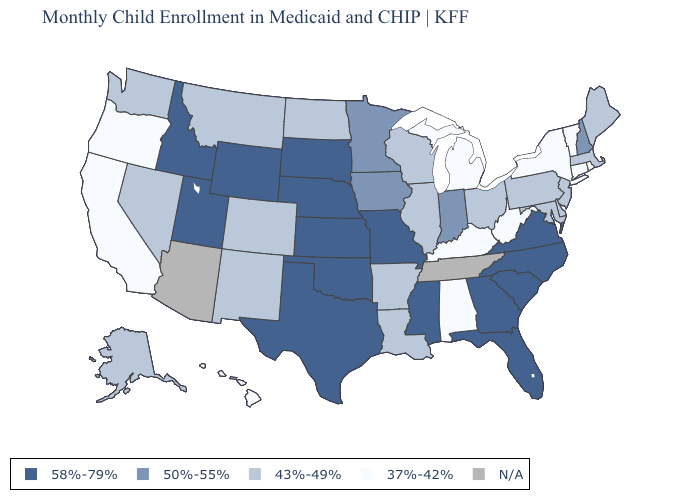What is the value of Louisiana?
Answer briefly. 43%-49%. Name the states that have a value in the range 58%-79%?
Be succinct. Florida, Georgia, Idaho, Kansas, Mississippi, Missouri, Nebraska, North Carolina, Oklahoma, South Carolina, South Dakota, Texas, Utah, Virginia, Wyoming. What is the value of Maryland?
Give a very brief answer. 43%-49%. What is the lowest value in states that border South Dakota?
Keep it brief. 43%-49%. Among the states that border Tennessee , does Georgia have the lowest value?
Keep it brief. No. Does Michigan have the highest value in the USA?
Give a very brief answer. No. What is the value of Texas?
Be succinct. 58%-79%. Does Alabama have the lowest value in the South?
Quick response, please. Yes. What is the value of Alabama?
Short answer required. 37%-42%. Among the states that border Nevada , which have the highest value?
Short answer required. Idaho, Utah. Name the states that have a value in the range 58%-79%?
Concise answer only. Florida, Georgia, Idaho, Kansas, Mississippi, Missouri, Nebraska, North Carolina, Oklahoma, South Carolina, South Dakota, Texas, Utah, Virginia, Wyoming. What is the value of Virginia?
Short answer required. 58%-79%. Name the states that have a value in the range 37%-42%?
Answer briefly. Alabama, California, Connecticut, Hawaii, Kentucky, Michigan, New York, Oregon, Rhode Island, Vermont, West Virginia. What is the lowest value in states that border North Carolina?
Concise answer only. 58%-79%. Among the states that border Alabama , which have the lowest value?
Be succinct. Florida, Georgia, Mississippi. 